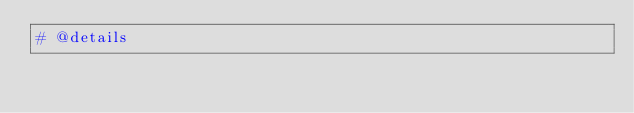Convert code to text. <code><loc_0><loc_0><loc_500><loc_500><_Python_># @details
</code> 